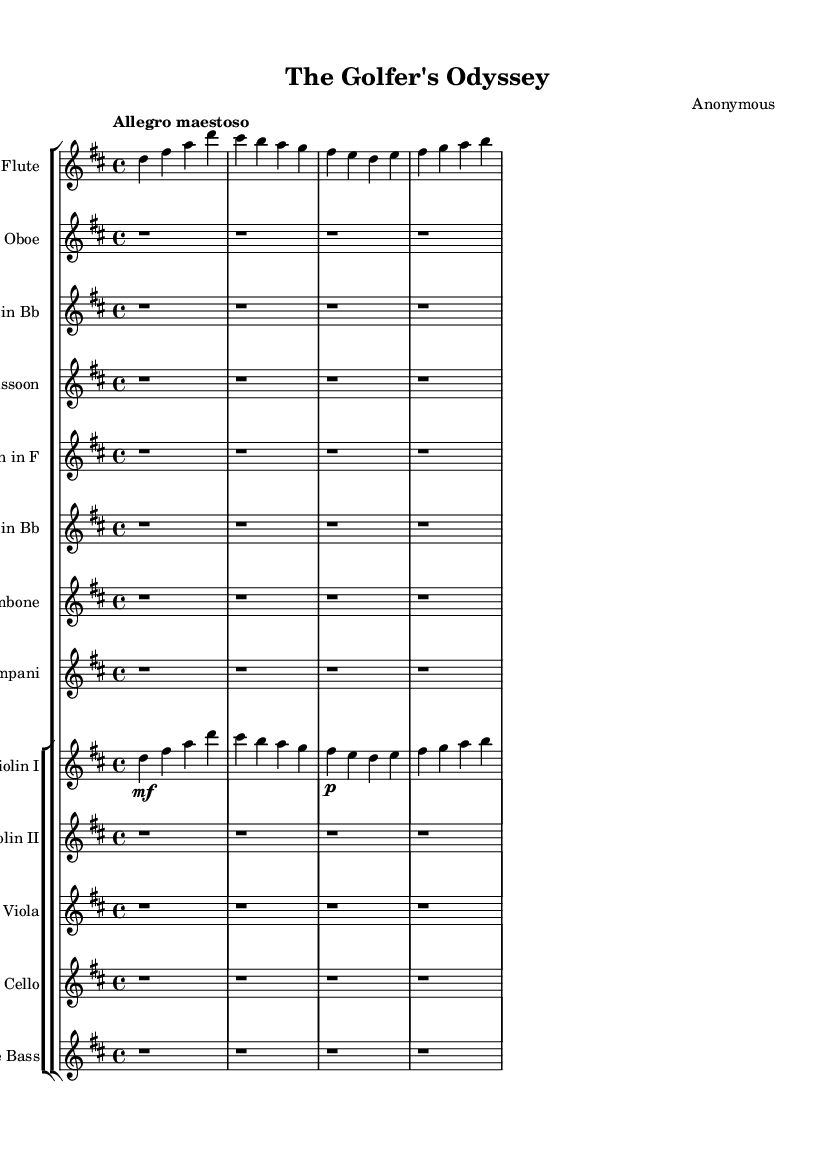What is the key signature of this music? The key signature is indicated at the beginning of the sheet music, showing two sharps (F# and C#), which corresponds to D major.
Answer: D major What is the time signature of this music? The time signature is located near the beginning of the score after the key signature, showing 4/4, which means there are four beats in a measure and a quarter note receives one beat.
Answer: 4/4 What is the tempo marking for this piece? The tempo is indicated at the start of the music under the global settings, specified as "Allegro maestoso," which suggests a fast and majestic tempo.
Answer: Allegro maestoso How many instruments are in the score? By counting each staff labeled for an instrument on the score, we can determine that there are a total of 12 instruments represented.
Answer: 12 What is the dynamic marking for Violin I on the first measure? The dynamic marking for Violin I is noted directly before the first note and is marked as "mf," which stands for mezzo-forte, indicating a moderately loud volume.
Answer: mf Which instruments are resting for the entire first section? The score shows that the staves for Oboe, Clarinet, Bassoon, Horn, Trumpet, Trombone, Timpani, Violin II, Viola, Cello, and Double Bass have rests throughout the first four measures, indicating they do not play during this section.
Answer: Oboe, Clarinet, Bassoon, Horn, Trumpet, Trombone, Timpani, Violin II, Viola, Cello, Double Bass What theme is depicted through the title of this piece? The title "The Golfer's Odyssey" suggests a narrative or journey theme related to golf, indicating that the music might evoke heroic or adventurous elements typically found in romantic symphonic poems.
Answer: Heroic adventure 